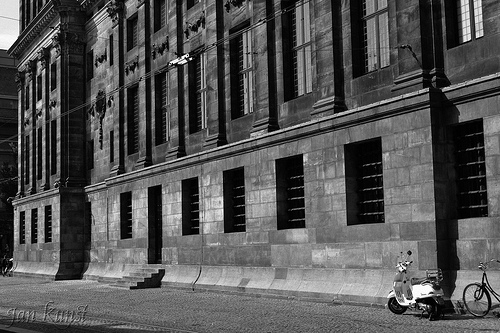Are the stairs in front of the doorway? Yes, the stairs are positioned in front of the doorway. 